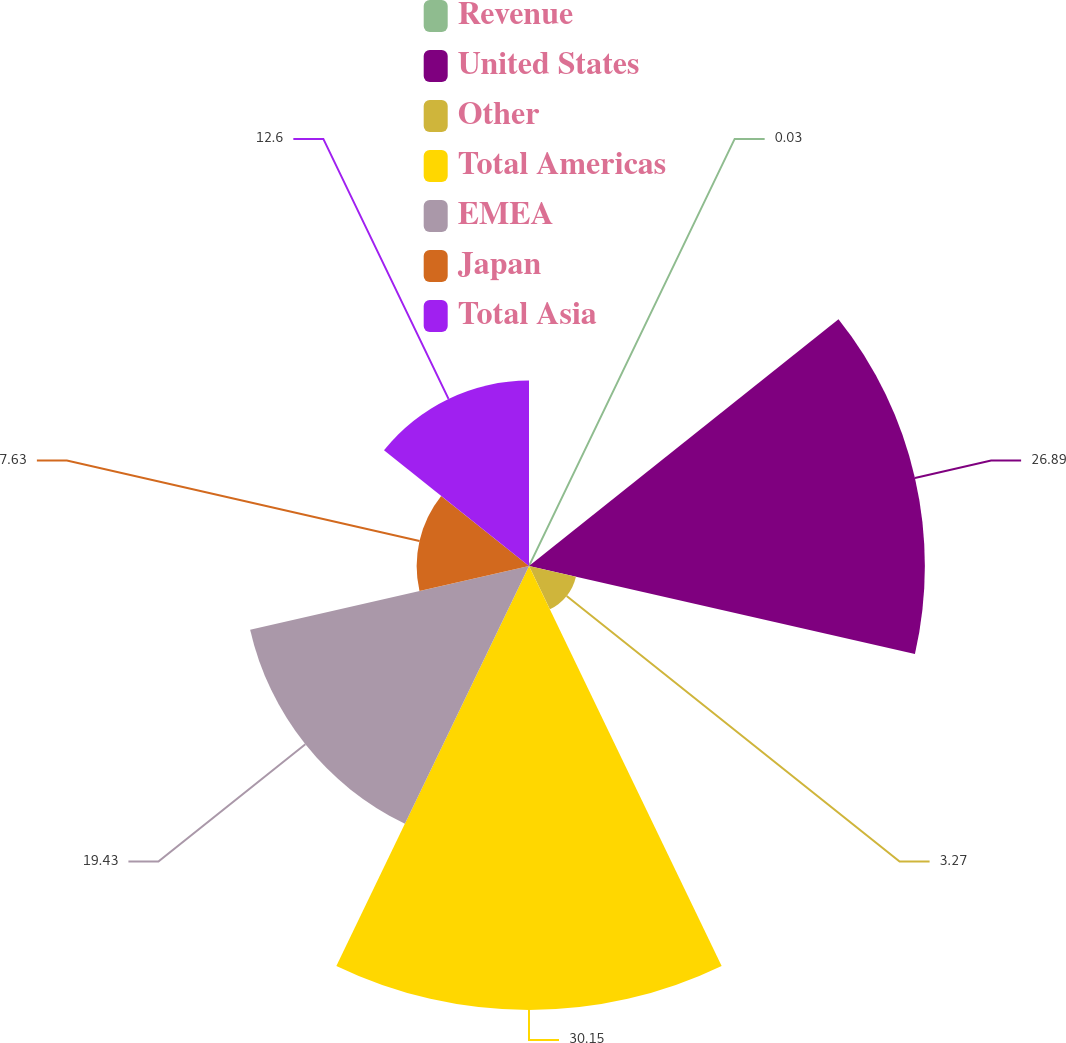<chart> <loc_0><loc_0><loc_500><loc_500><pie_chart><fcel>Revenue<fcel>United States<fcel>Other<fcel>Total Americas<fcel>EMEA<fcel>Japan<fcel>Total Asia<nl><fcel>0.03%<fcel>26.89%<fcel>3.27%<fcel>30.16%<fcel>19.43%<fcel>7.63%<fcel>12.6%<nl></chart> 